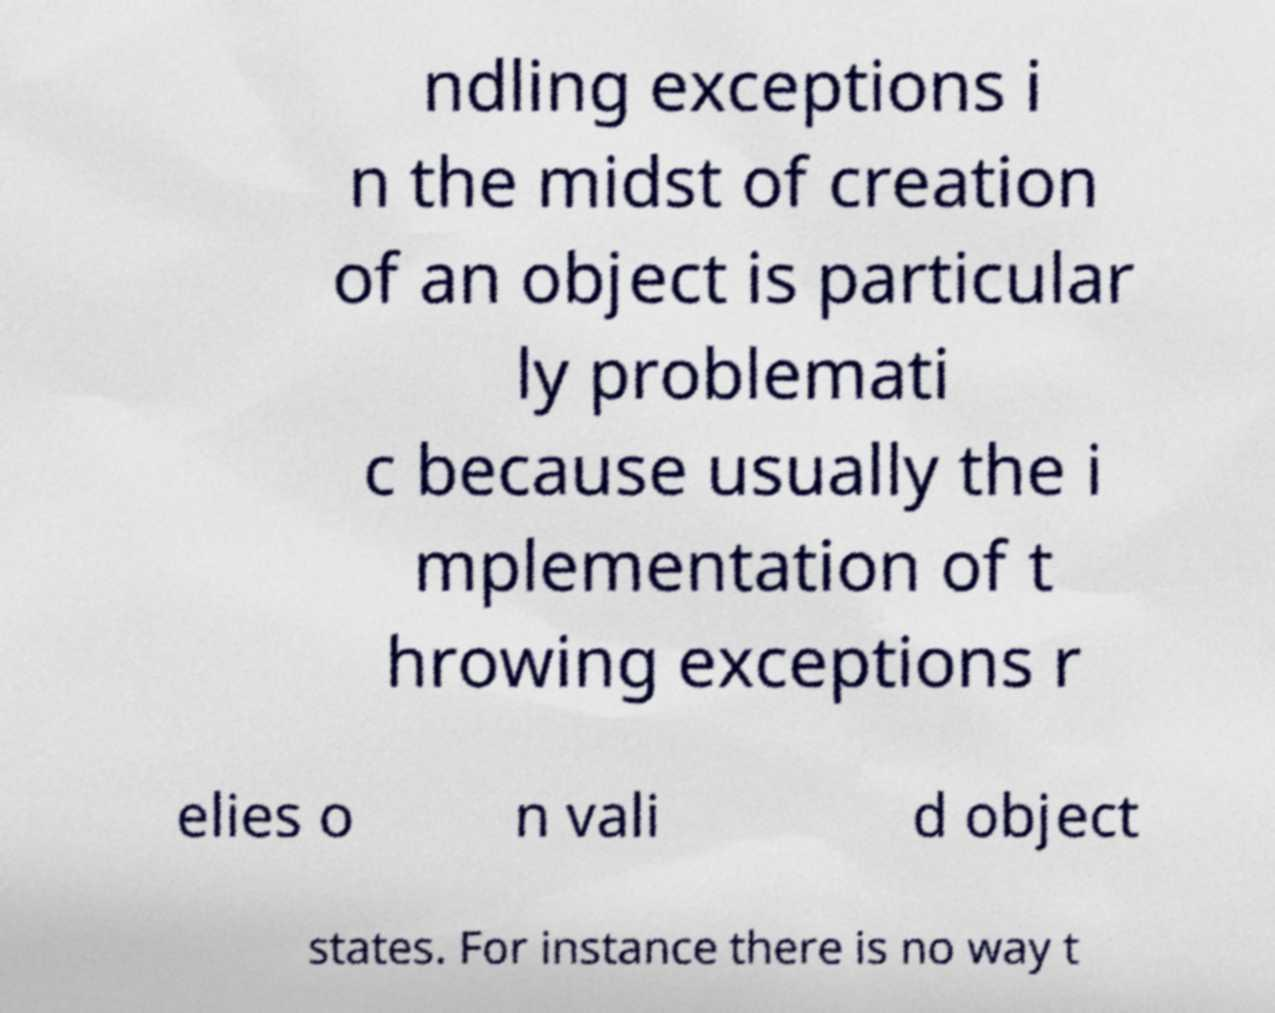Can you read and provide the text displayed in the image?This photo seems to have some interesting text. Can you extract and type it out for me? ndling exceptions i n the midst of creation of an object is particular ly problemati c because usually the i mplementation of t hrowing exceptions r elies o n vali d object states. For instance there is no way t 